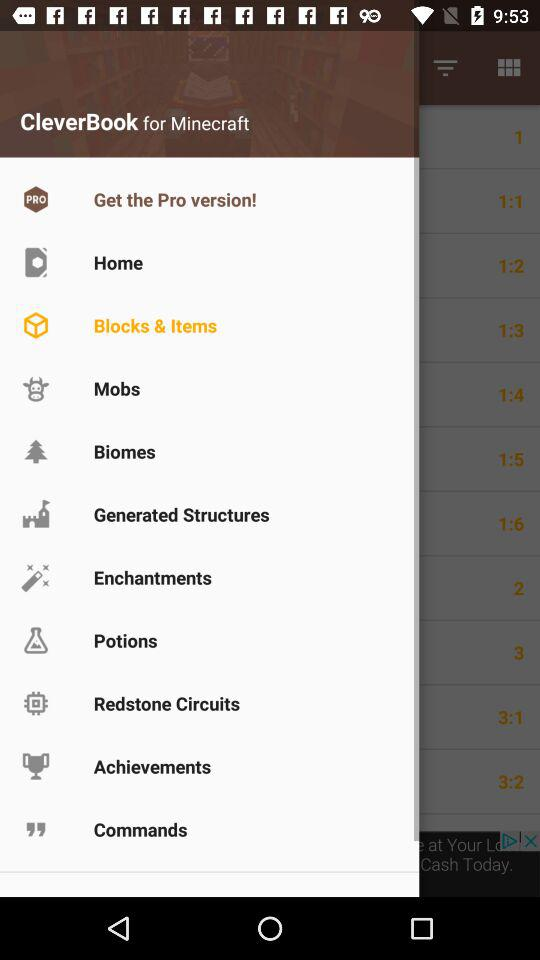What is the application name? The application name is "CleverBook for Minecraft". 